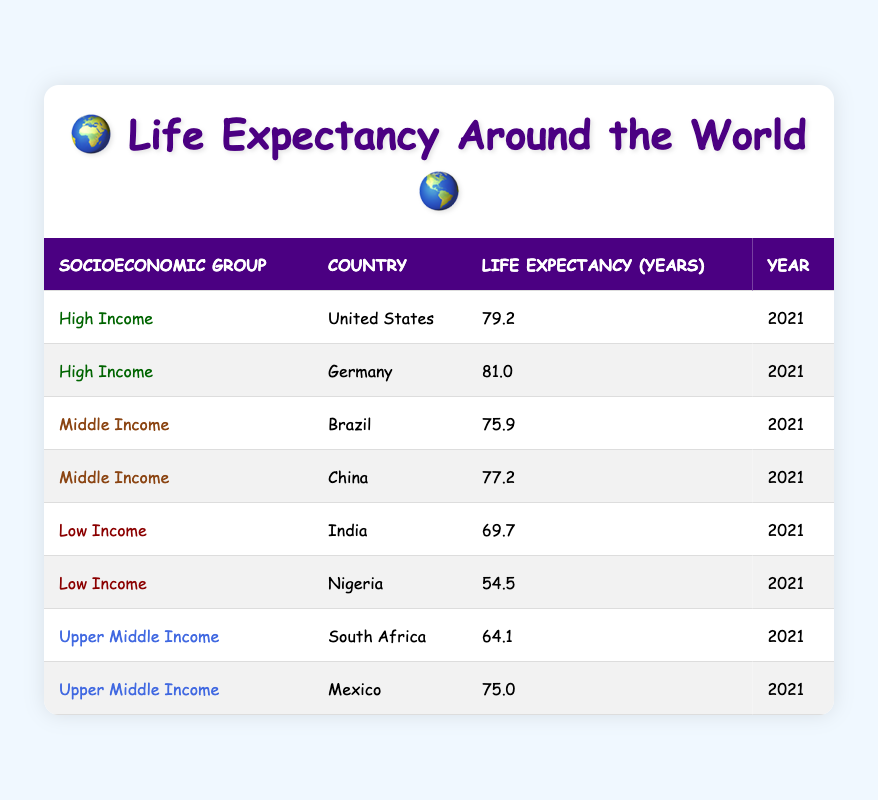What is the life expectancy of the United States in 2021? Directly referencing the table, the life expectancy for the United States listed under the high-income socioeconomic group in the year 2021 is 79.2 years.
Answer: 79.2 Which country has the highest life expectancy among the listed countries? From the table, Germany under the high-income group has the highest life expectancy of 81.0 years, compared to the others such as the United States (79.2) and Brazil (75.9).
Answer: Germany Is the life expectancy for India higher than that of Nigeria? Looking at the life expectancy values, India has 69.7 years, while Nigeria has 54.5 years. Since 69.7 is greater than 54.5, the statement is true.
Answer: Yes What is the average life expectancy of the middle-income countries listed? Adding the life expectancy of Brazil (75.9) and China (77.2) gives 153.1 years. There are 2 middle-income countries. Dividing 153.1 by 2 results in 76.55 years.
Answer: 76.55 Which socioeconomic group has the lowest life expectancy average? The low-income group includes India (69.7) and Nigeria (54.5). Their sum is 124.2 and dividing by 2 gives an average of 62.1 years, which is lower than the averages of the other groups.
Answer: Low Income Is it true that all upper-middle-income countries have a life expectancy above 70 years? Checking the life expectancy for South Africa (64.1) and Mexico (75.0), only Mexico is above 70 years, making the statement false.
Answer: No What is the difference in life expectancy between the highest and the lowest in the table? The highest life expectancy is Germany’s 81.0 years and the lowest is Nigeria’s 54.5 years. The difference is 81.0 - 54.5 = 26.5 years.
Answer: 26.5 In which year was the life expectancy for South Africa recorded, and what is that value? The life expectancy is recorded under the year 2021, showing that South Africa has a life expectancy of 64.1 years.
Answer: 64.1 (2021) 